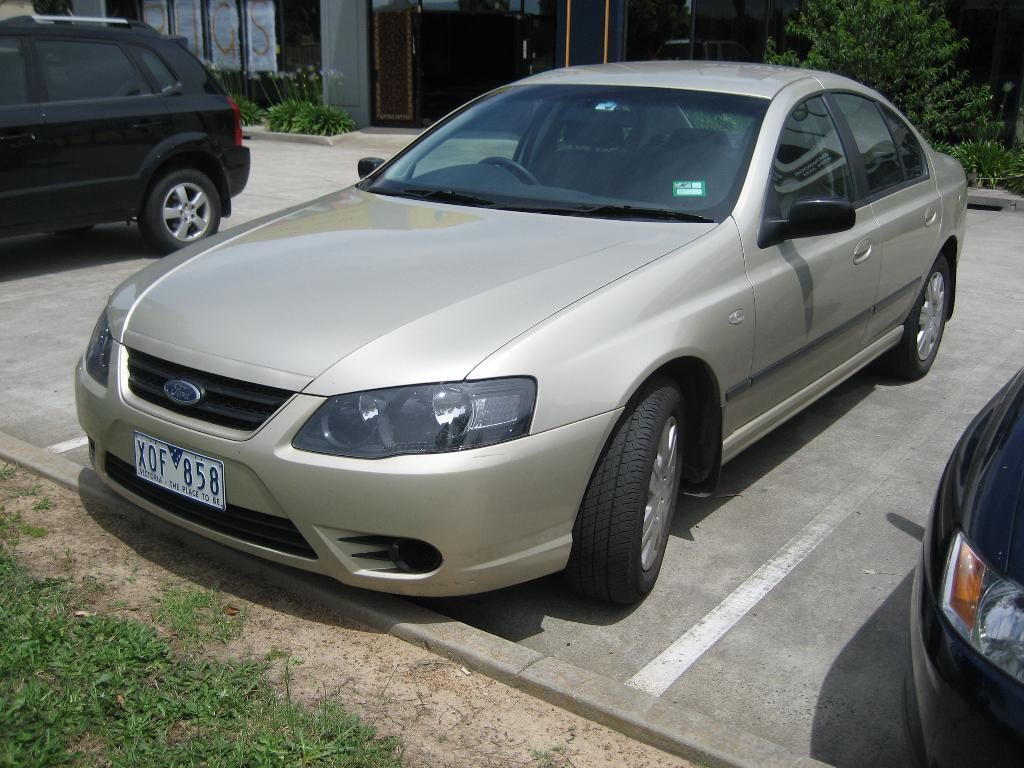What can be seen parked on the road in the image? There are cars parked on the road in the image. What type of vegetation is visible in the image? There is grass and shrubs visible in the image. What architectural feature can be seen in the image? There are doors visible in the image. What is located in the background of the image? There is a building in the background of the image. What type of rice is being cooked in the image? There is no rice present in the image. How many sisters can be seen in the image? There are no sisters present in the image. 